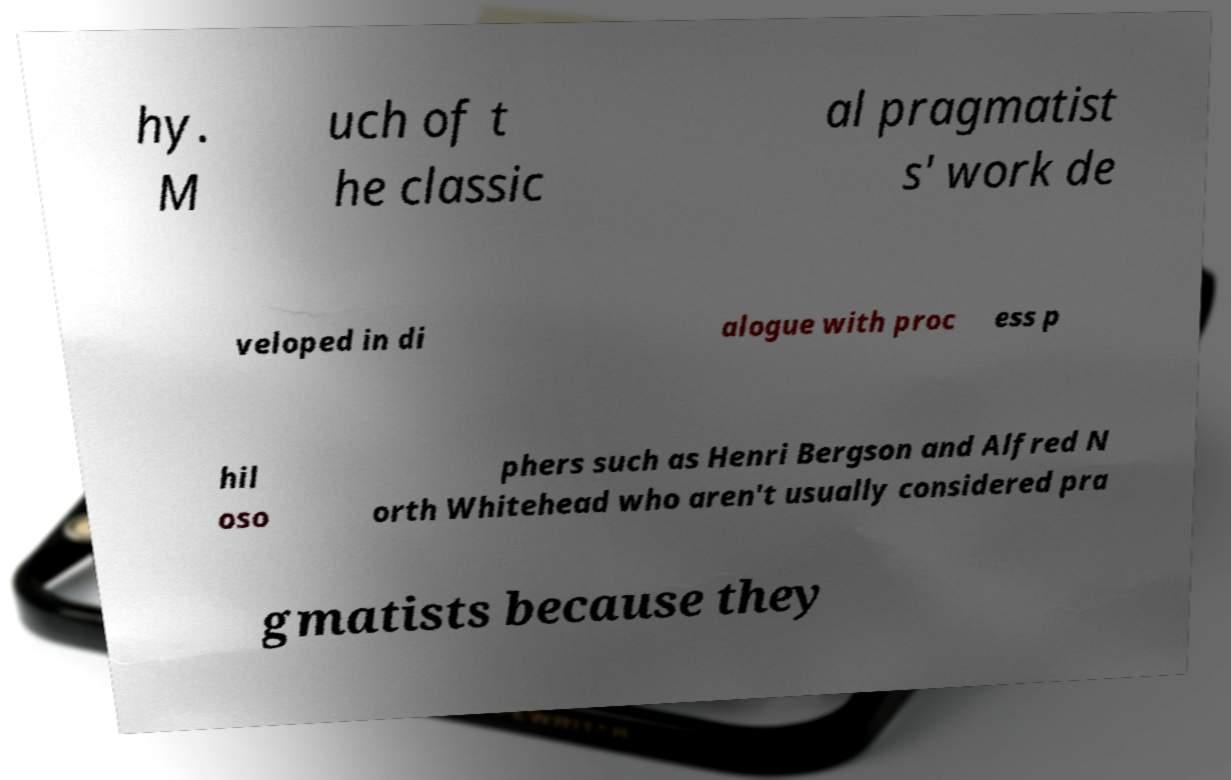What messages or text are displayed in this image? I need them in a readable, typed format. hy. M uch of t he classic al pragmatist s' work de veloped in di alogue with proc ess p hil oso phers such as Henri Bergson and Alfred N orth Whitehead who aren't usually considered pra gmatists because they 